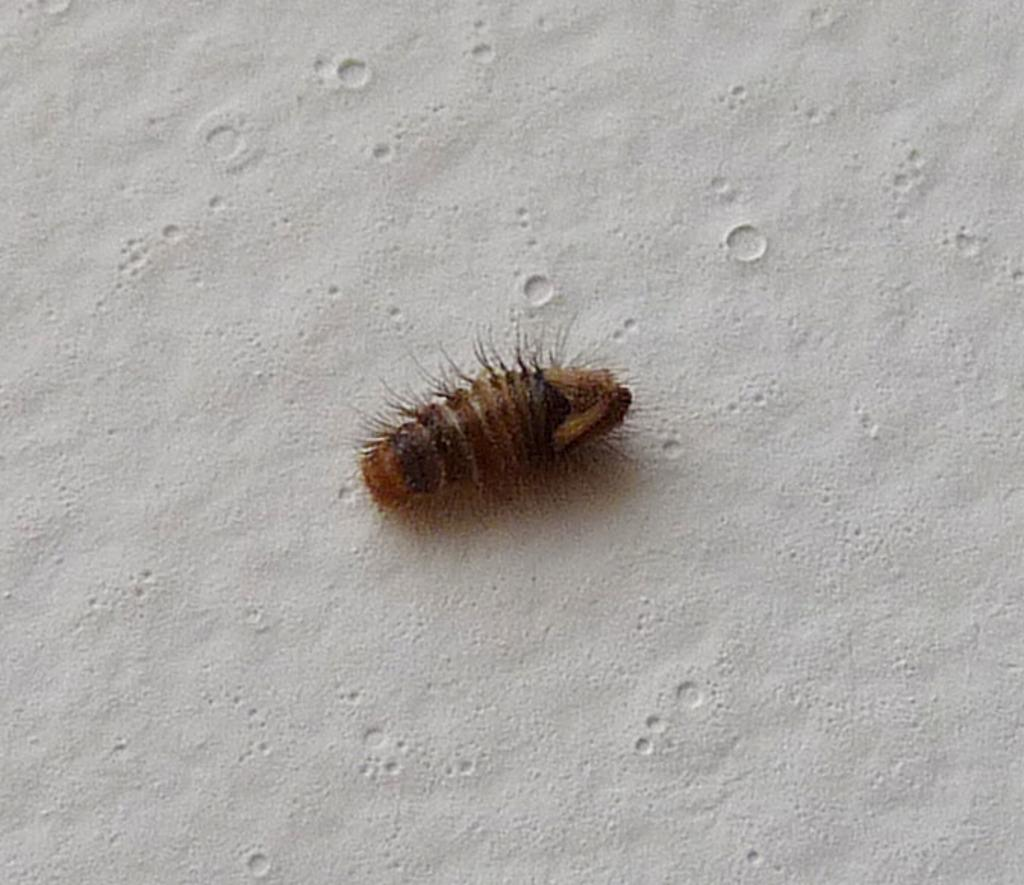What type of creature can be seen in the image? There is an insect in the image. Where is the insect located in the image? The insect is on the ground. What type of attention is the government giving to the hen in the image? There is no hen present in the image, and the government is not depicted in the image. 